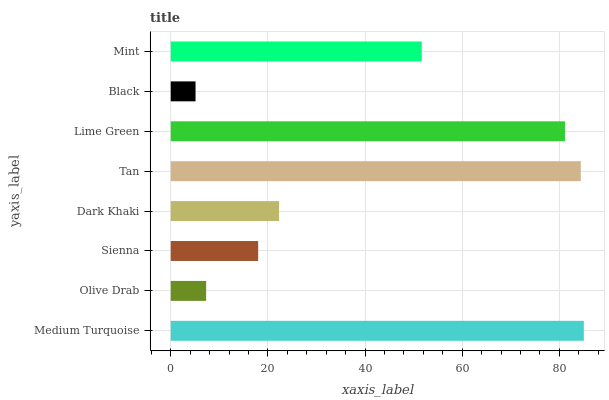Is Black the minimum?
Answer yes or no. Yes. Is Medium Turquoise the maximum?
Answer yes or no. Yes. Is Olive Drab the minimum?
Answer yes or no. No. Is Olive Drab the maximum?
Answer yes or no. No. Is Medium Turquoise greater than Olive Drab?
Answer yes or no. Yes. Is Olive Drab less than Medium Turquoise?
Answer yes or no. Yes. Is Olive Drab greater than Medium Turquoise?
Answer yes or no. No. Is Medium Turquoise less than Olive Drab?
Answer yes or no. No. Is Mint the high median?
Answer yes or no. Yes. Is Dark Khaki the low median?
Answer yes or no. Yes. Is Medium Turquoise the high median?
Answer yes or no. No. Is Sienna the low median?
Answer yes or no. No. 